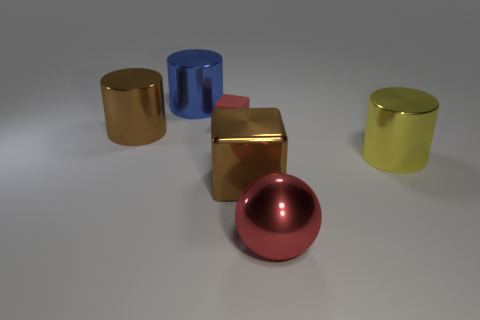What is the shape of the red thing that is the same size as the blue metal object?
Your response must be concise. Sphere. Is there a tiny shiny block that has the same color as the metallic ball?
Ensure brevity in your answer.  No. The red ball has what size?
Your response must be concise. Large. Is the yellow object made of the same material as the blue cylinder?
Offer a terse response. Yes. There is a cylinder on the right side of the big brown object in front of the yellow cylinder; how many rubber objects are in front of it?
Offer a very short reply. 0. There is a metallic object right of the red shiny sphere; what is its shape?
Offer a very short reply. Cylinder. How many other things are there of the same material as the big red thing?
Your answer should be compact. 4. Does the big block have the same color as the rubber cube?
Your answer should be compact. No. Is the number of large shiny blocks on the right side of the big brown shiny cube less than the number of large red metallic balls that are behind the large blue object?
Offer a terse response. No. The shiny thing that is the same shape as the matte object is what color?
Provide a short and direct response. Brown. 